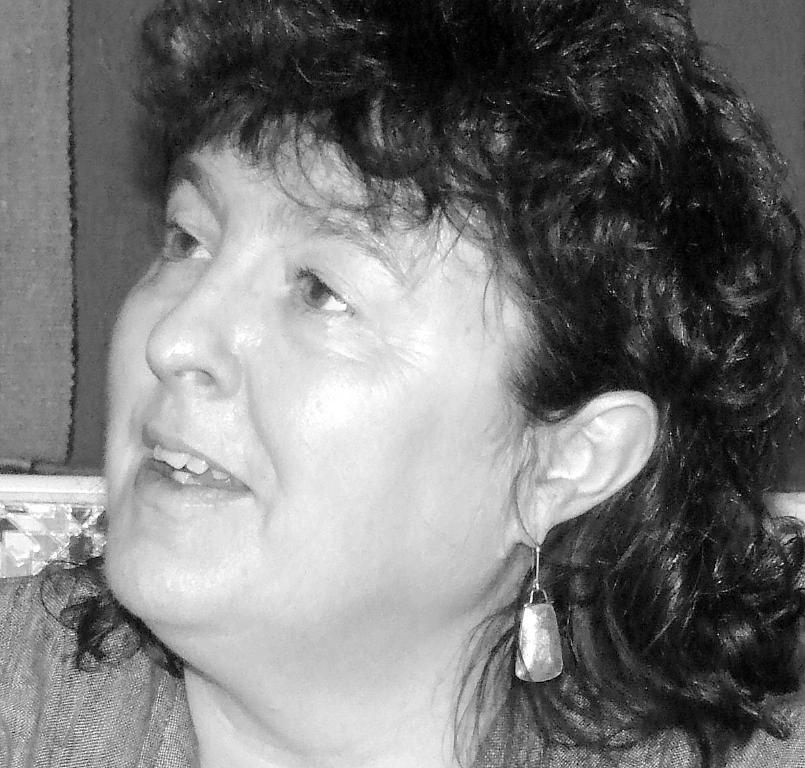What is the color scheme of the image? The image is black and white. Can you describe the main subject of the image? There is a person in the image. What type of pot is the person sitting on in the image? There is no pot present in the image, and the person is not sitting on any object. What level of authority does the person have in the image, as indicated by the presence of a throne? There is no throne present in the image, and the person's level of authority cannot be determined from the image. 